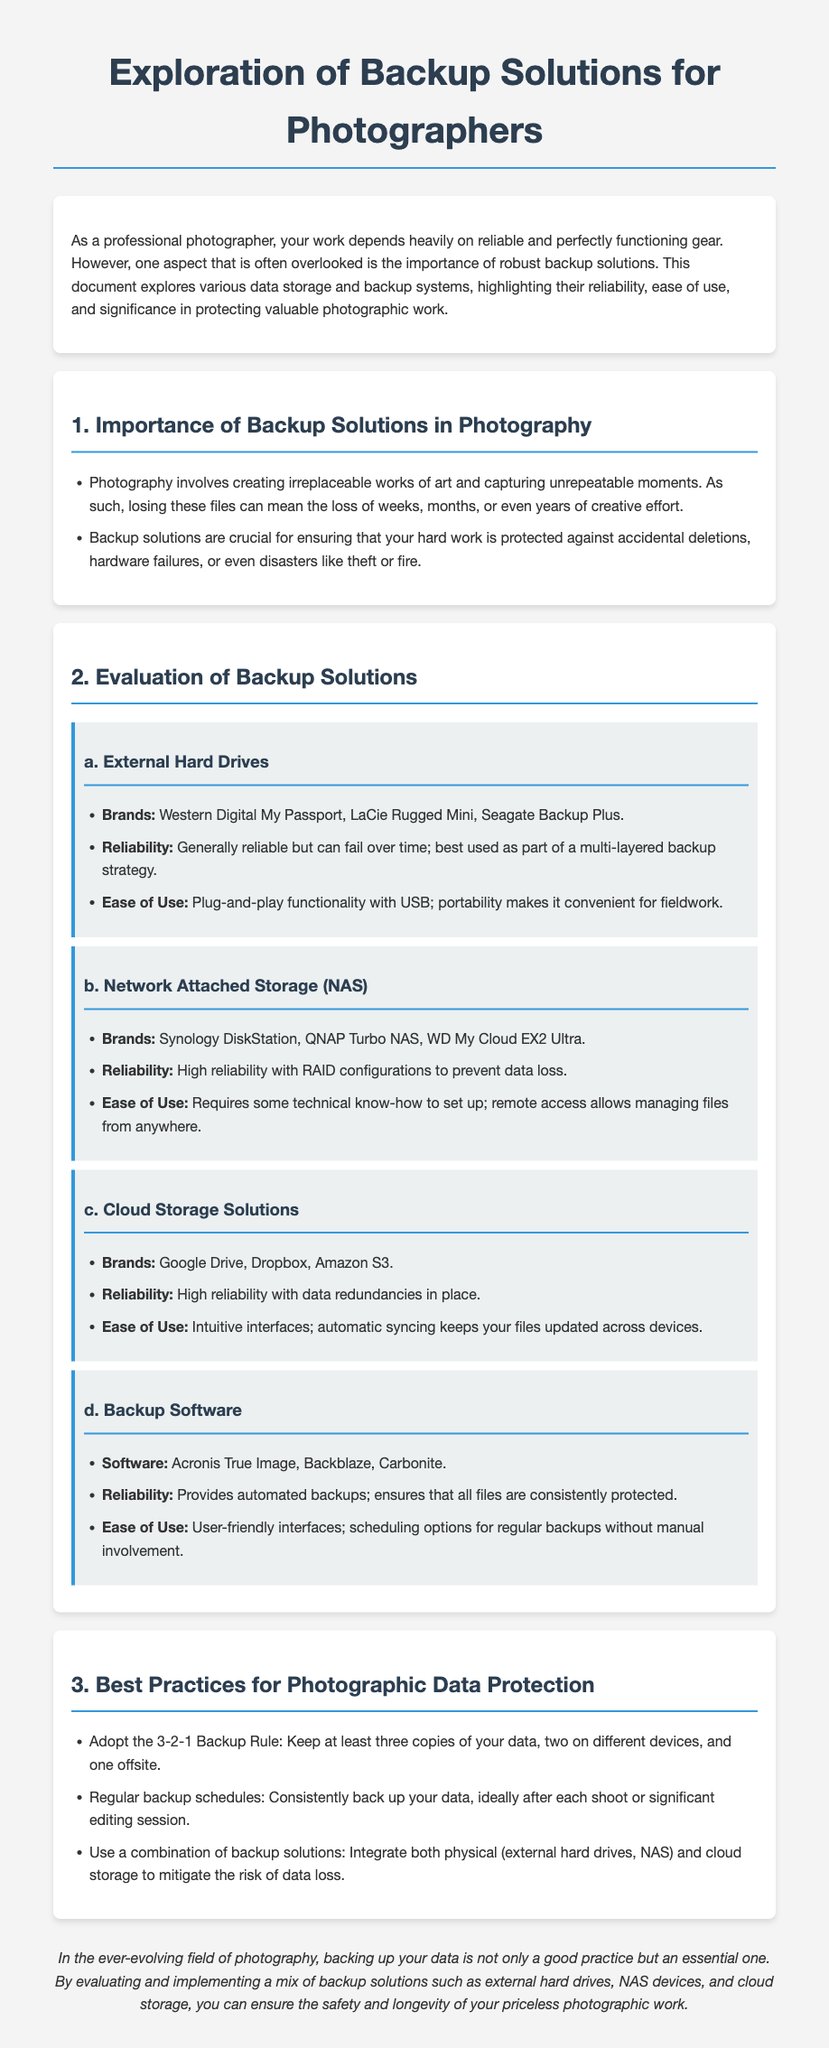What are the brands of external hard drives mentioned? The document lists specific brands of external hard drives in the evaluation section.
Answer: Western Digital My Passport, LaCie Rugged Mini, Seagate Backup Plus What is the 3-2-1 Backup Rule? The document provides a backup strategy in the best practices section related to data protection.
Answer: Keep at least three copies of your data, two on different devices, and one offsite Which cloud storage solutions are highlighted? Cloud storage solutions are specified in the evaluation section along with their brands.
Answer: Google Drive, Dropbox, Amazon S3 What type of installation does Network Attached Storage (NAS) require? The ease of use section for NAS indicates the level of technical know-how needed for installation.
Answer: Some technical know-how What is the primary benefit of backup software? The reliability section of backup software discusses its main advantage in data protection.
Answer: Provides automated backups What is a recommended action after each photo shoot? The document outlines a practice in the best practices section meant for data protection consistency.
Answer: Regular backup schedules Which external hard drives are noted for portability? The ease of use section addresses the convenience of external hard drives for photographers in the field.
Answer: Portability makes it convenient for fieldwork What type of configuration enhances the reliability of NAS devices? The reliability description for NAS devices mentions a specific technology used for data safeguarding.
Answer: RAID configurations 